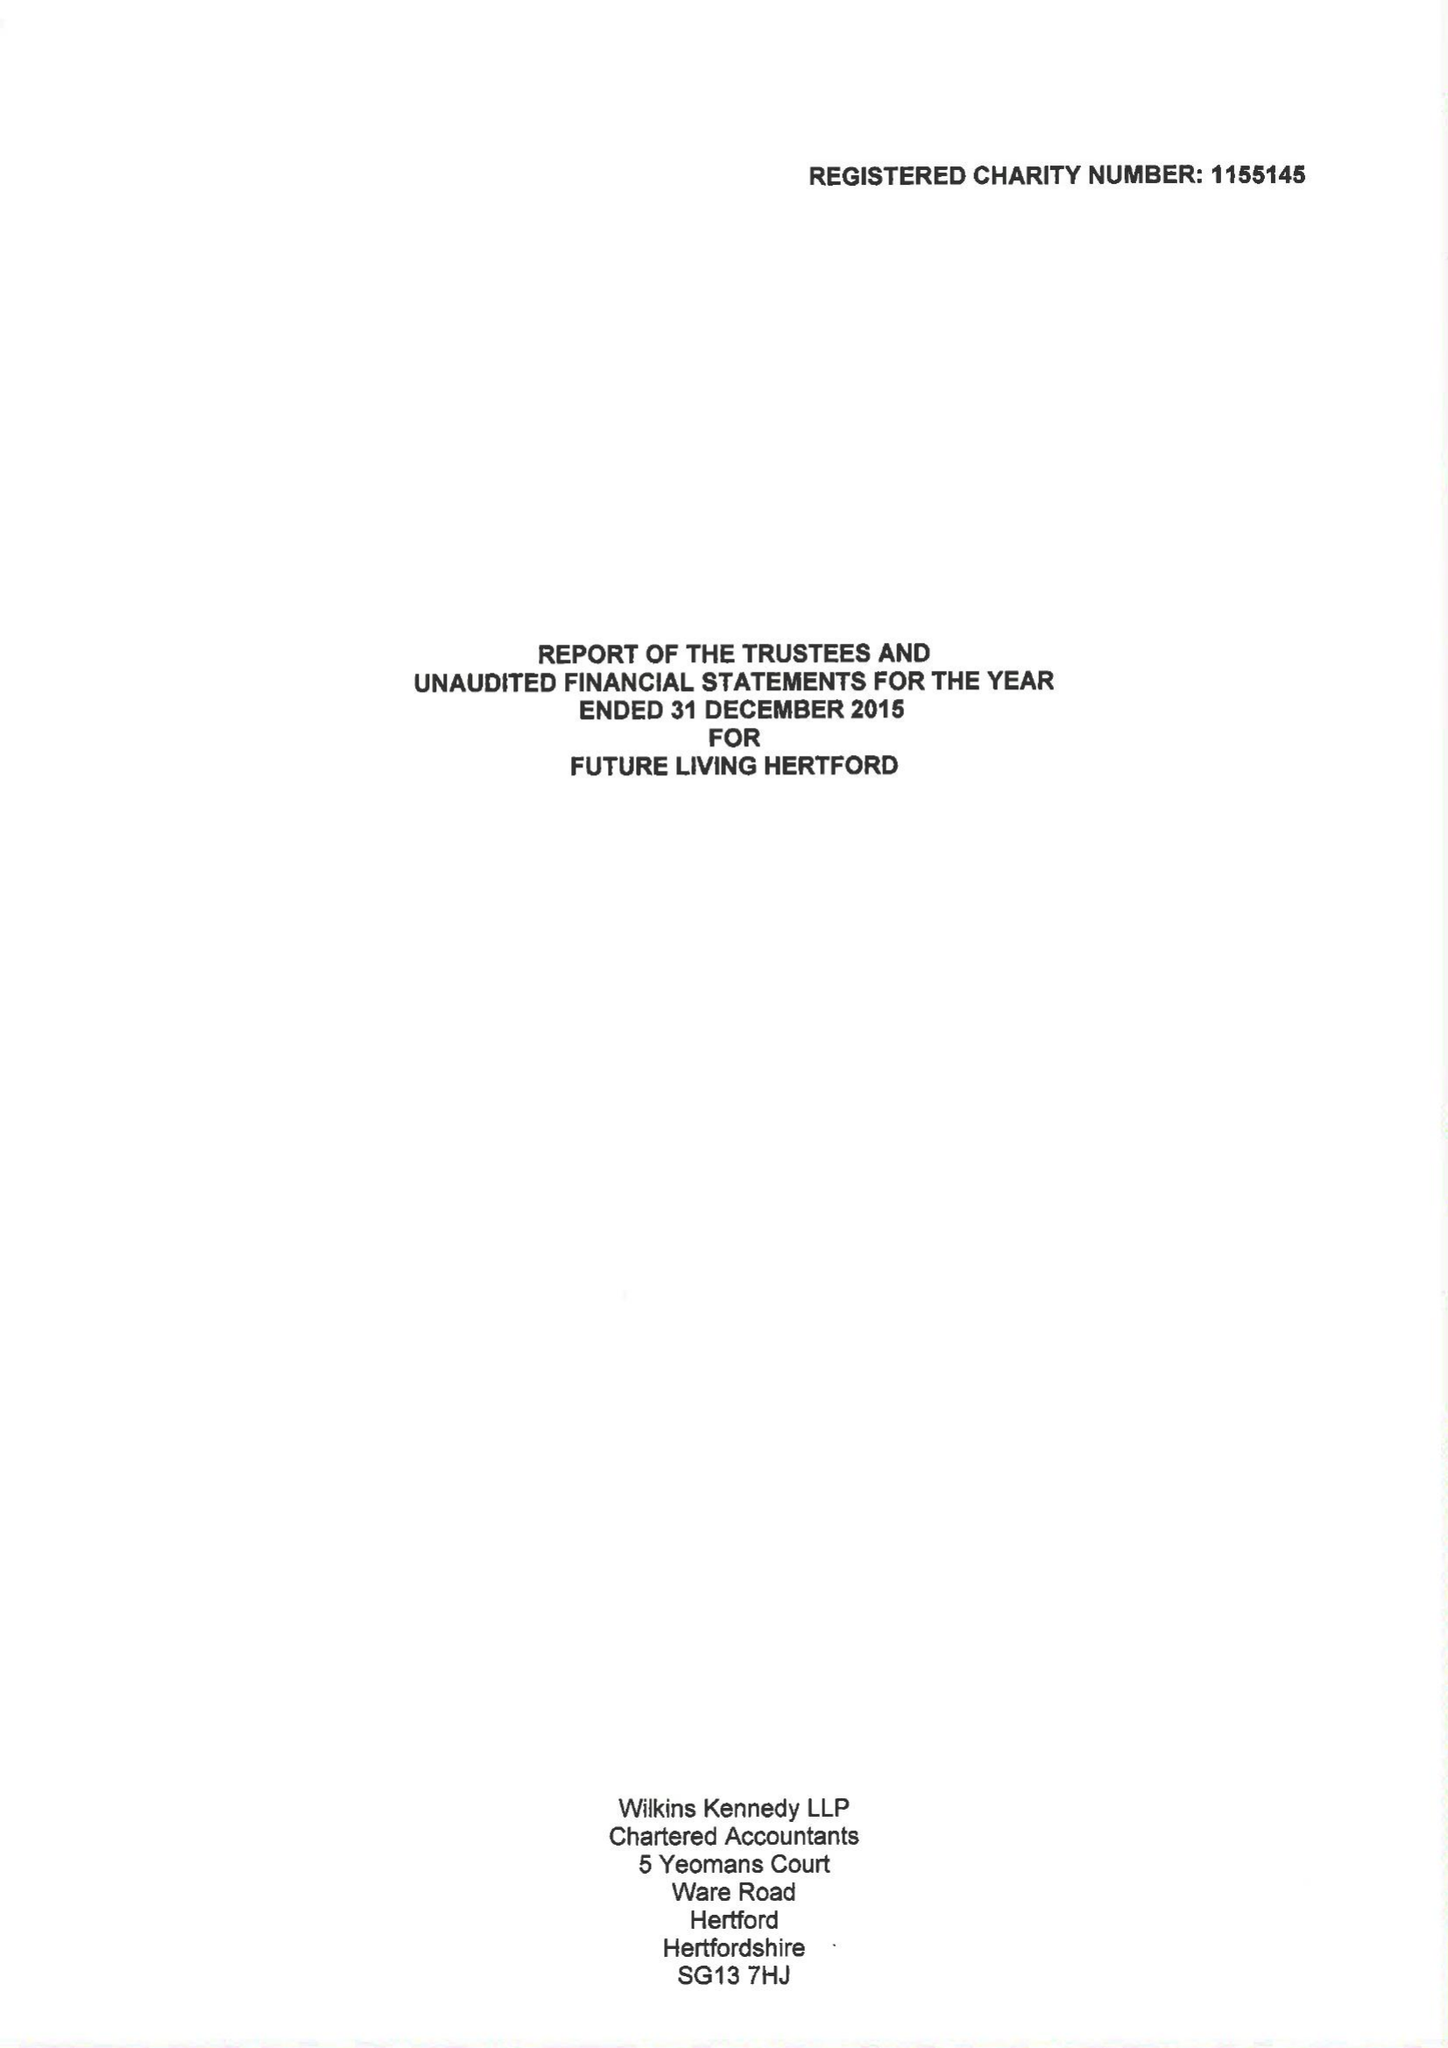What is the value for the report_date?
Answer the question using a single word or phrase. 2015-12-31 